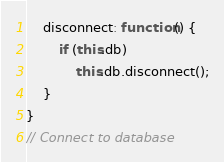<code> <loc_0><loc_0><loc_500><loc_500><_JavaScript_>
	disconnect: function() {
		if (this.db)
			this.db.disconnect();
	}
}
// Connect to database
</code> 